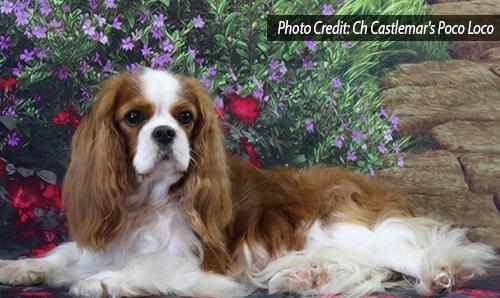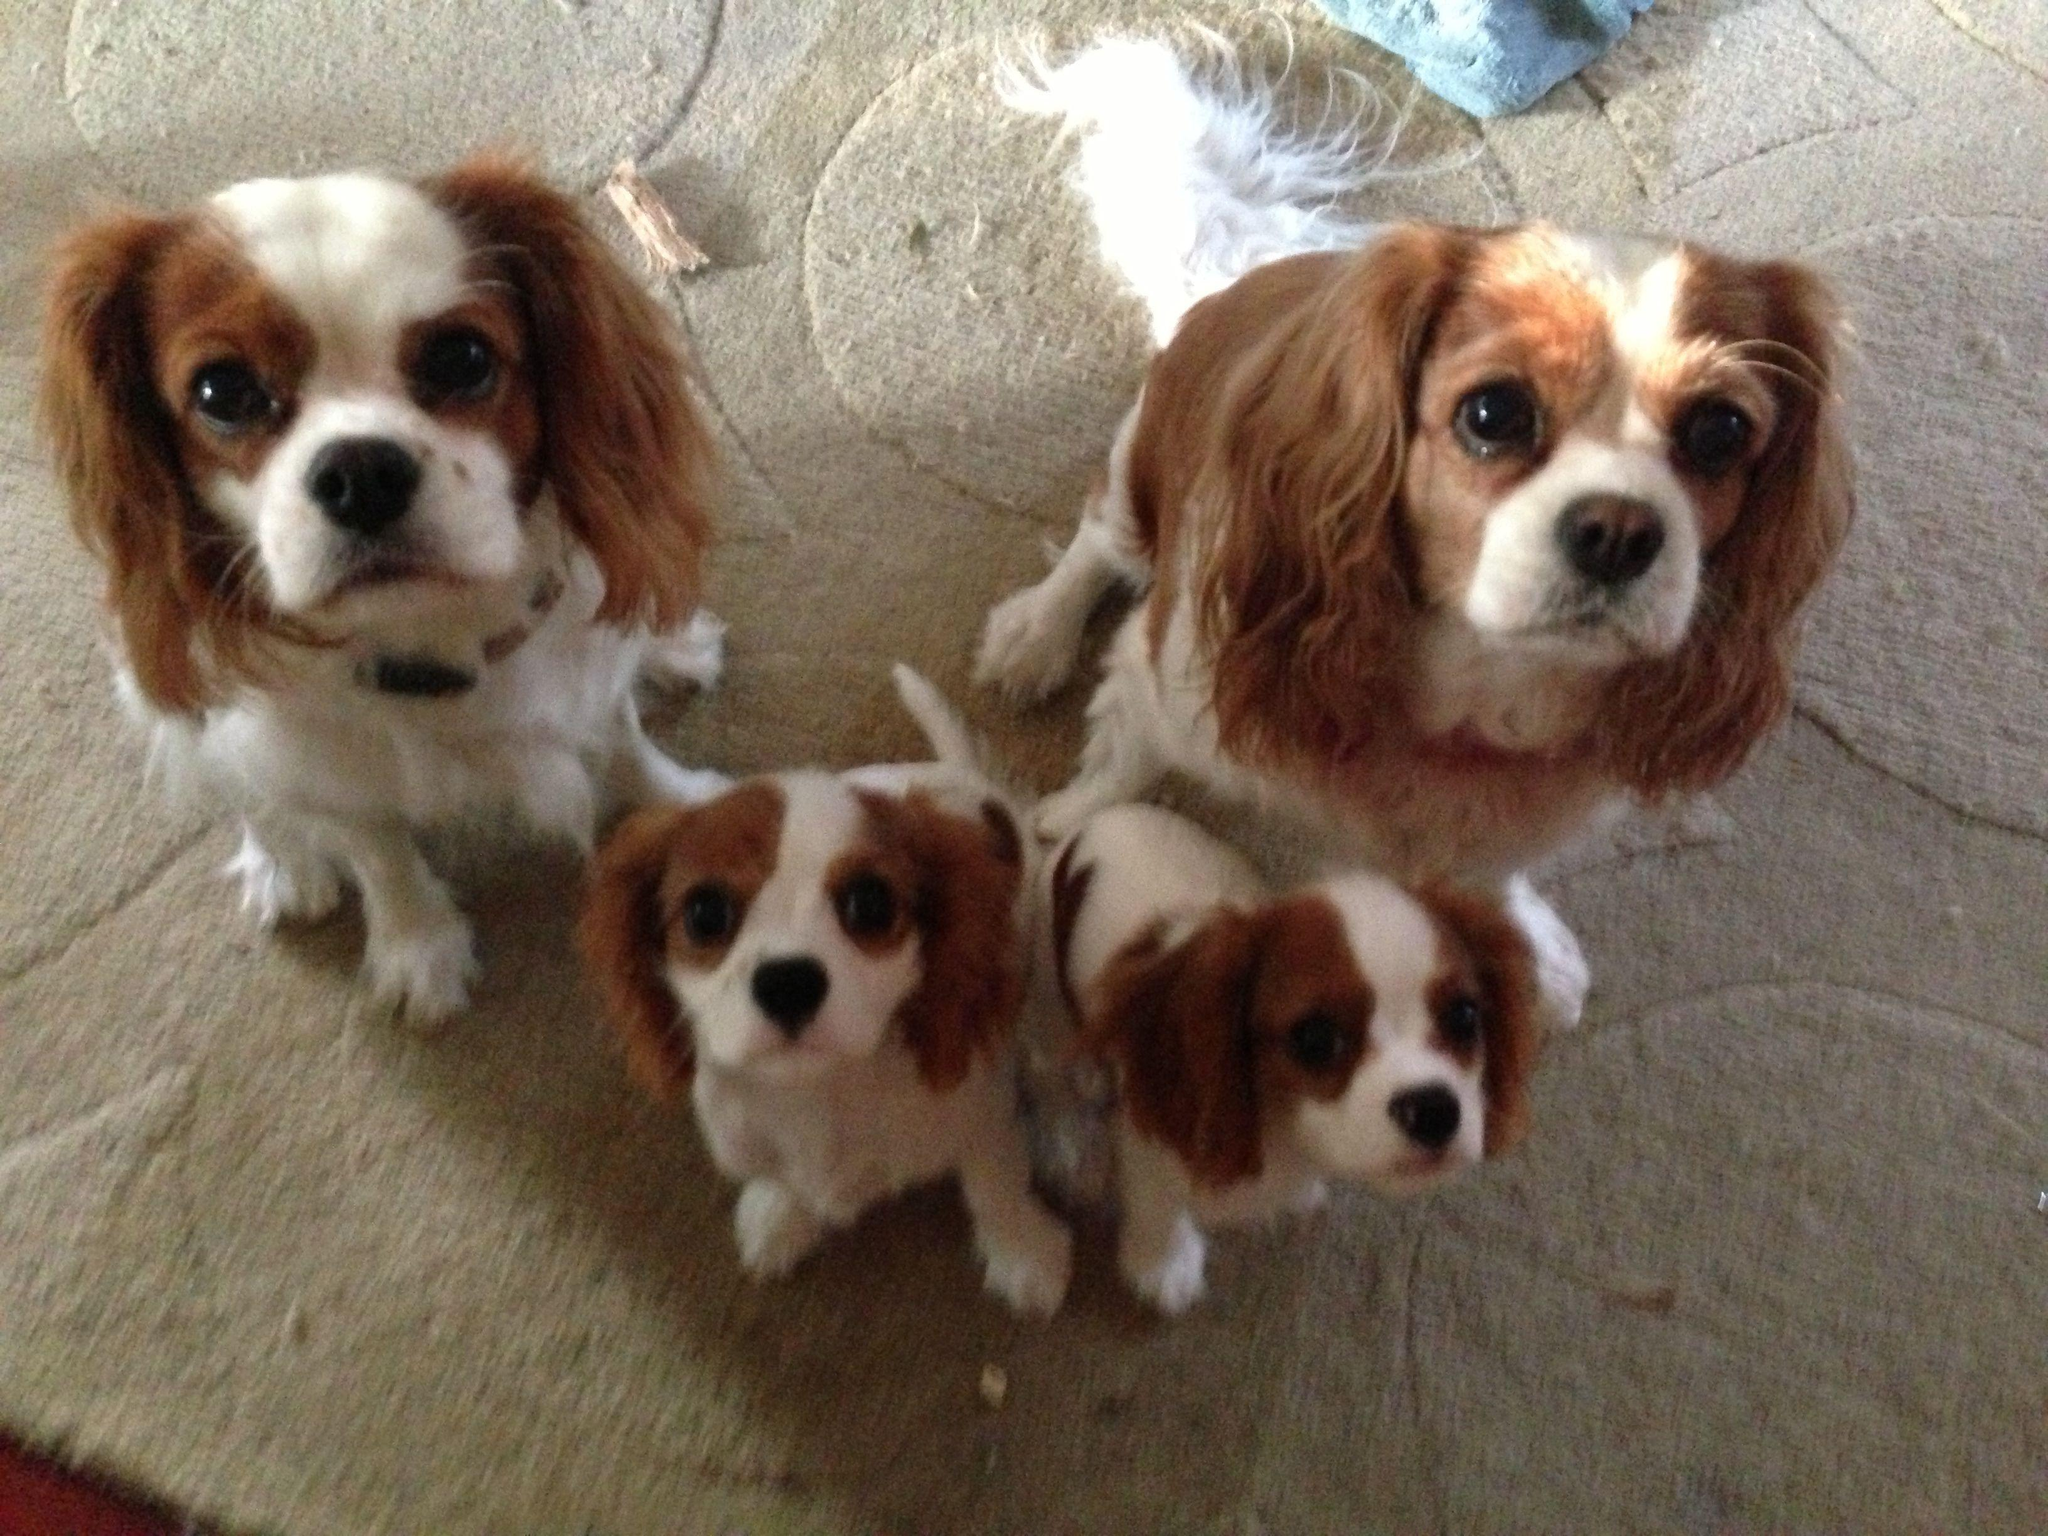The first image is the image on the left, the second image is the image on the right. For the images shown, is this caption "There are five dogs in total, with more dogs on the right." true? Answer yes or no. Yes. The first image is the image on the left, the second image is the image on the right. For the images displayed, is the sentence "There are 5 dogs shown." factually correct? Answer yes or no. Yes. 